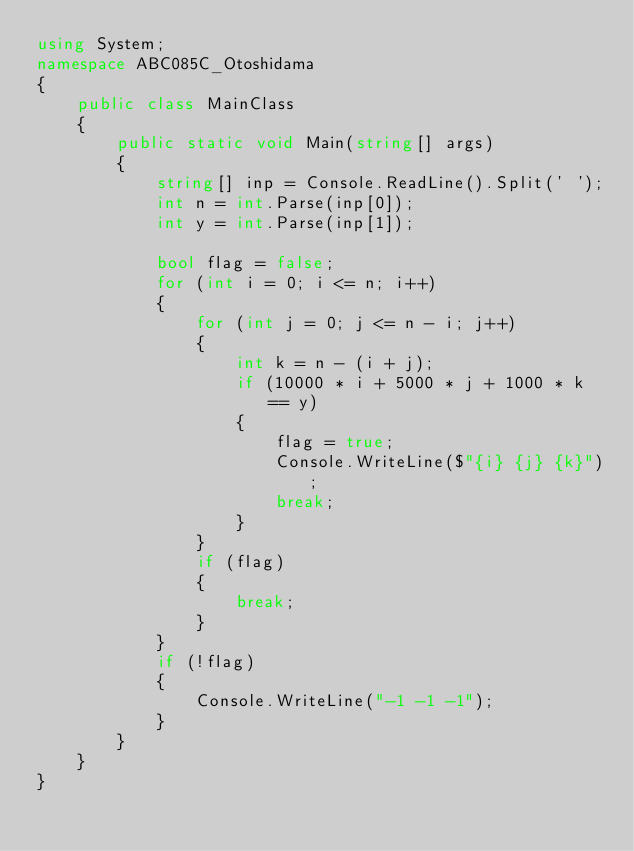Convert code to text. <code><loc_0><loc_0><loc_500><loc_500><_C#_>using System;
namespace ABC085C_Otoshidama
{
    public class MainClass
    {
        public static void Main(string[] args)
        {
            string[] inp = Console.ReadLine().Split(' ');
            int n = int.Parse(inp[0]);
            int y = int.Parse(inp[1]);

            bool flag = false;
            for (int i = 0; i <= n; i++)
            {
                for (int j = 0; j <= n - i; j++)
                {
                    int k = n - (i + j);
                    if (10000 * i + 5000 * j + 1000 * k == y)
                    {
                        flag = true;
                        Console.WriteLine($"{i} {j} {k}");
                        break;
                    }
                }
                if (flag)
                {
                    break;
                }
            }
            if (!flag)
            {
                Console.WriteLine("-1 -1 -1");
            }
        }
    }
}
</code> 